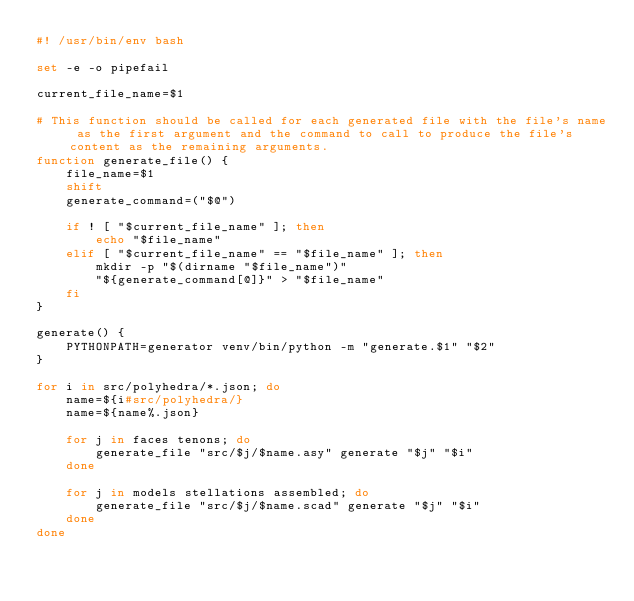<code> <loc_0><loc_0><loc_500><loc_500><_Bash_>#! /usr/bin/env bash

set -e -o pipefail

current_file_name=$1

# This function should be called for each generated file with the file's name as the first argument and the command to call to produce the file's content as the remaining arguments.
function generate_file() {
	file_name=$1
	shift
	generate_command=("$@")
	
	if ! [ "$current_file_name" ]; then
		echo "$file_name"
	elif [ "$current_file_name" == "$file_name" ]; then
		mkdir -p "$(dirname "$file_name")"
		"${generate_command[@]}" > "$file_name"
	fi
}

generate() {
	PYTHONPATH=generator venv/bin/python -m "generate.$1" "$2"
}

for i in src/polyhedra/*.json; do
	name=${i#src/polyhedra/}
	name=${name%.json}

	for j in faces tenons; do
		generate_file "src/$j/$name.asy" generate "$j" "$i"
	done
	
	for j in models stellations assembled; do
		generate_file "src/$j/$name.scad" generate "$j" "$i"
	done
done
</code> 